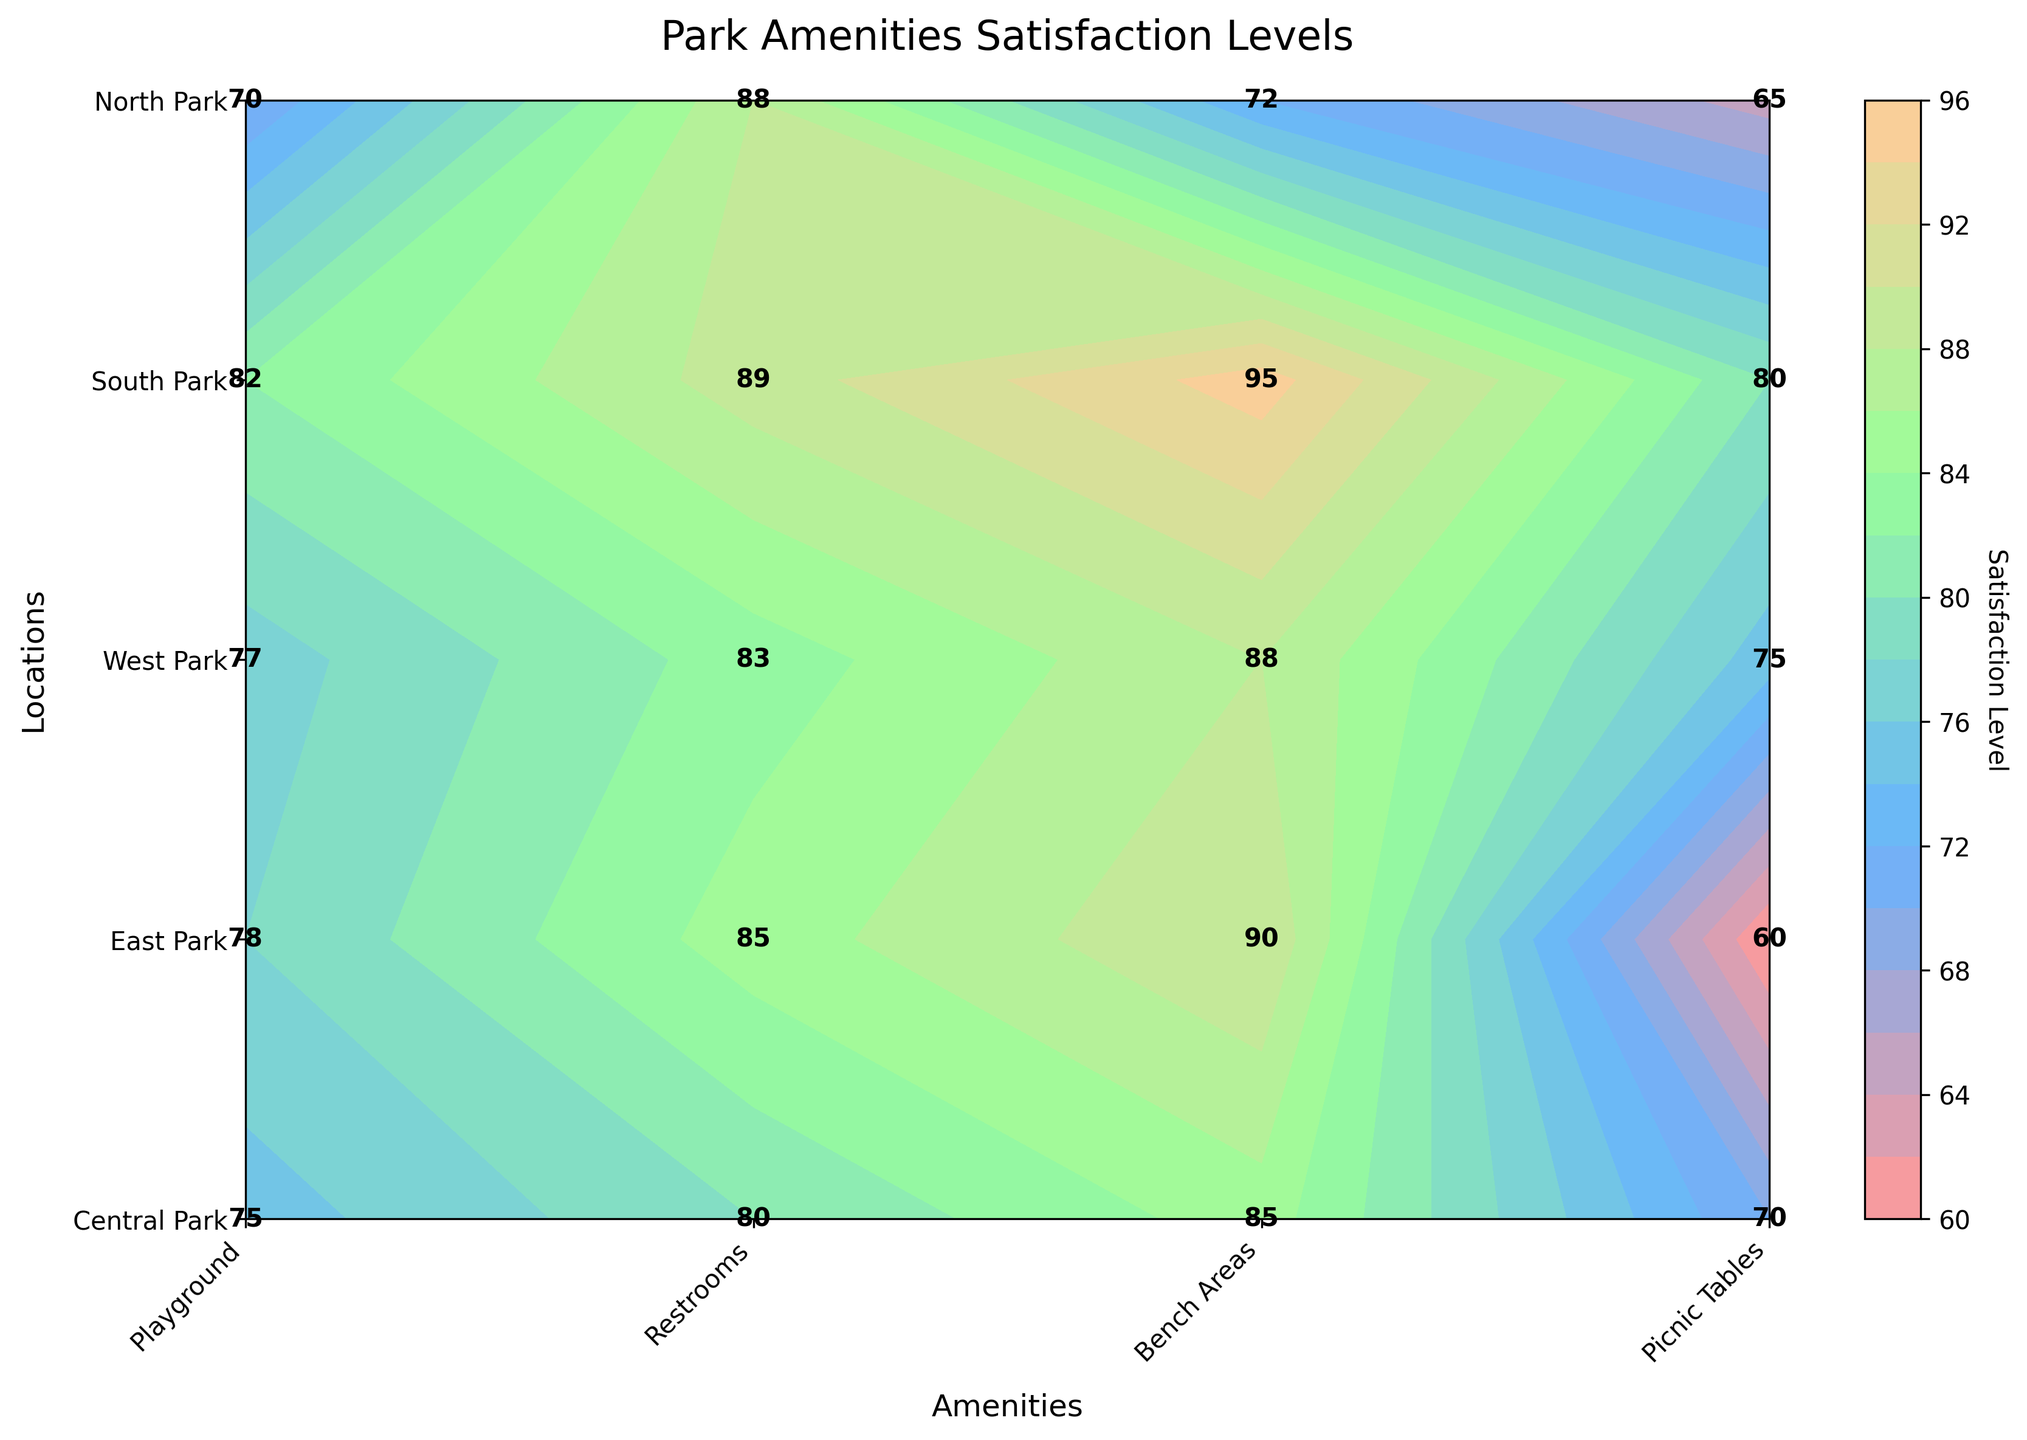What is the title of the figure? The title is typically displayed at the top of the figure, above the data visualization. In this instance, the title is "Park Amenities Satisfaction Levels" which is indicated in the code.
Answer: Park Amenities Satisfaction Levels Which park location has the highest satisfaction level for playgrounds? To find this, look for the highest number in the row corresponding to 'Playground' across all park locations. South Park has the highest satisfaction level of 95.
Answer: South Park Which amenity in Central Park has the lowest satisfaction level? By looking at the data labels in the Central Park row, the lowest satisfaction level is 70 for Restrooms.
Answer: Restrooms What is the average satisfaction level for Bench Areas across all parks? The satisfaction levels for Bench Areas are 75 in Central Park, 78 in East Park, 70 in West Park, 82 in South Park, and 77 in North Park. Calculate the average by summing these values and dividing by the number of locations: (75 + 78 + 70 + 82 + 77)/5 = 76.4
Answer: 76.4 Compare the satisfaction levels for Restrooms between East Park and North Park. Which park has a higher satisfaction level? Comparing the satisfaction levels shown for Restrooms, East Park has 60 and North Park has 75. North Park has a higher satisfaction level.
Answer: North Park Which park has the most consistent (i.e., least variation in) satisfaction levels across all amenities? To determine this, calculate the range of satisfaction levels for each park and identify the smallest range. Central Park: 85-70=15, East Park: 90-60=30, West Park: 88-65=23, South Park: 95-80=15, North Park: 88-75=13. The smallest range is 13 in North Park, indicating the most consistent satisfaction levels.
Answer: North Park What is the difference in satisfaction level for Picnic Tables between Central Park and West Park? The satisfaction levels for Picnic Tables are 80 in Central Park and 88 in West Park. The difference is 88 - 80 = 8.
Answer: 8 How does the satisfaction level for Restrooms in West Park compare to the overall average satisfaction level for Restrooms? To find the overall average, sum the satisfaction levels for Restrooms across all parks and divide by the number of parks. Values: 70 (Central), 60 (East), 65 (West), 80 (South), 75 (North). Average: (70+60+65+80+75)/5 = 70. The satisfaction level for Restrooms in West Park is 65, which is lower than the overall average of 70.
Answer: Lower Which location and amenity combination shows the highest satisfaction level in the entire figure? To identify this, scan the entire dataset for the highest satisfaction level. The highest value is 95, which is for the Playground in South Park.
Answer: Playground in South Park Is there any location where satisfaction levels are uniformly high (above 80) for all amenities? By checking each row of satisfaction levels: Only South Park has satisfaction levels above 80 for all amenities (Playground 95, Restrooms 80, Bench Areas 82, Picnic Tables 89).
Answer: South Park 